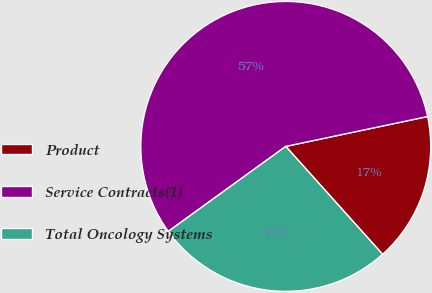<chart> <loc_0><loc_0><loc_500><loc_500><pie_chart><fcel>Product<fcel>Service Contracts(1)<fcel>Total Oncology Systems<nl><fcel>16.67%<fcel>56.67%<fcel>26.67%<nl></chart> 